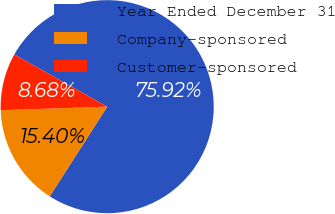<chart> <loc_0><loc_0><loc_500><loc_500><pie_chart><fcel>Year Ended December 31<fcel>Company-sponsored<fcel>Customer-sponsored<nl><fcel>75.92%<fcel>15.4%<fcel>8.68%<nl></chart> 